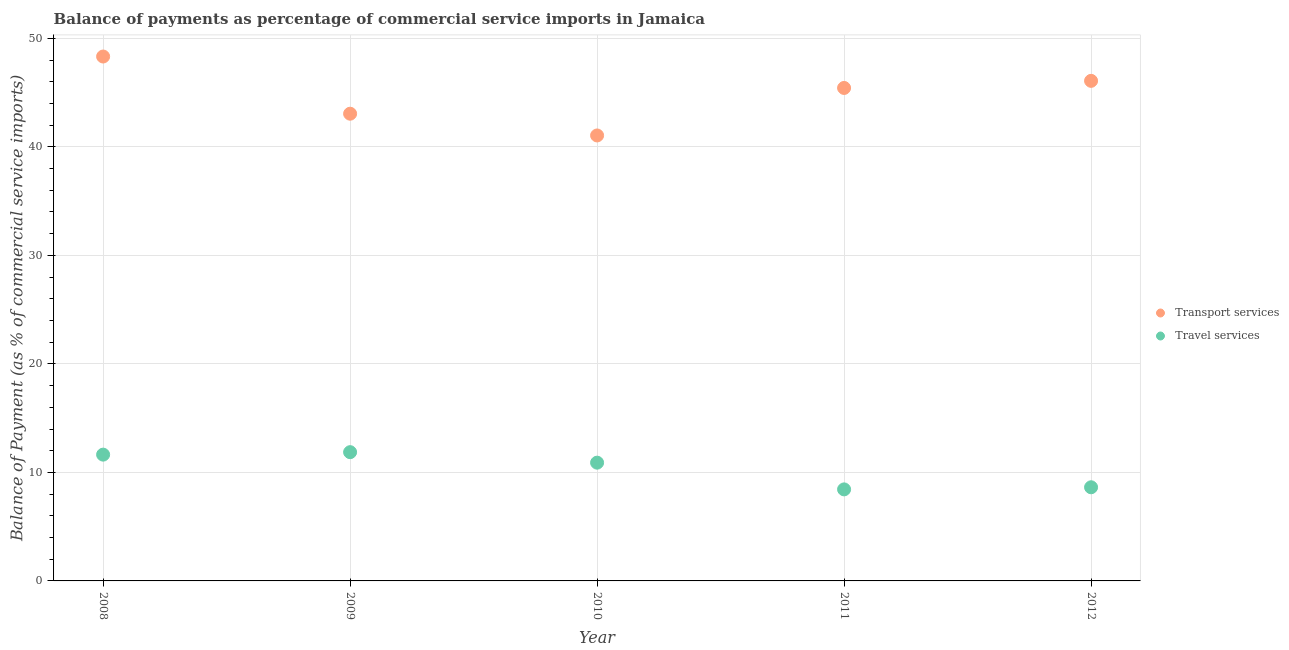How many different coloured dotlines are there?
Your response must be concise. 2. What is the balance of payments of travel services in 2012?
Make the answer very short. 8.63. Across all years, what is the maximum balance of payments of travel services?
Ensure brevity in your answer.  11.87. Across all years, what is the minimum balance of payments of travel services?
Provide a succinct answer. 8.44. What is the total balance of payments of travel services in the graph?
Make the answer very short. 51.47. What is the difference between the balance of payments of transport services in 2009 and that in 2012?
Your answer should be compact. -3.03. What is the difference between the balance of payments of transport services in 2011 and the balance of payments of travel services in 2008?
Make the answer very short. 33.79. What is the average balance of payments of travel services per year?
Your answer should be very brief. 10.29. In the year 2011, what is the difference between the balance of payments of travel services and balance of payments of transport services?
Provide a succinct answer. -36.99. In how many years, is the balance of payments of transport services greater than 26 %?
Offer a terse response. 5. What is the ratio of the balance of payments of travel services in 2008 to that in 2011?
Give a very brief answer. 1.38. Is the balance of payments of transport services in 2009 less than that in 2010?
Ensure brevity in your answer.  No. What is the difference between the highest and the second highest balance of payments of travel services?
Your answer should be very brief. 0.23. What is the difference between the highest and the lowest balance of payments of travel services?
Provide a succinct answer. 3.43. Is the balance of payments of transport services strictly greater than the balance of payments of travel services over the years?
Your answer should be very brief. Yes. Is the balance of payments of travel services strictly less than the balance of payments of transport services over the years?
Give a very brief answer. Yes. How many dotlines are there?
Your response must be concise. 2. How many years are there in the graph?
Make the answer very short. 5. Are the values on the major ticks of Y-axis written in scientific E-notation?
Keep it short and to the point. No. How are the legend labels stacked?
Offer a very short reply. Vertical. What is the title of the graph?
Provide a succinct answer. Balance of payments as percentage of commercial service imports in Jamaica. Does "Female entrants" appear as one of the legend labels in the graph?
Your answer should be compact. No. What is the label or title of the X-axis?
Your answer should be compact. Year. What is the label or title of the Y-axis?
Provide a short and direct response. Balance of Payment (as % of commercial service imports). What is the Balance of Payment (as % of commercial service imports) of Transport services in 2008?
Your response must be concise. 48.33. What is the Balance of Payment (as % of commercial service imports) of Travel services in 2008?
Offer a very short reply. 11.64. What is the Balance of Payment (as % of commercial service imports) of Transport services in 2009?
Provide a short and direct response. 43.06. What is the Balance of Payment (as % of commercial service imports) in Travel services in 2009?
Offer a terse response. 11.87. What is the Balance of Payment (as % of commercial service imports) of Transport services in 2010?
Provide a short and direct response. 41.05. What is the Balance of Payment (as % of commercial service imports) of Travel services in 2010?
Make the answer very short. 10.9. What is the Balance of Payment (as % of commercial service imports) of Transport services in 2011?
Provide a succinct answer. 45.43. What is the Balance of Payment (as % of commercial service imports) in Travel services in 2011?
Your response must be concise. 8.44. What is the Balance of Payment (as % of commercial service imports) of Transport services in 2012?
Ensure brevity in your answer.  46.09. What is the Balance of Payment (as % of commercial service imports) in Travel services in 2012?
Your answer should be compact. 8.63. Across all years, what is the maximum Balance of Payment (as % of commercial service imports) of Transport services?
Your response must be concise. 48.33. Across all years, what is the maximum Balance of Payment (as % of commercial service imports) in Travel services?
Offer a very short reply. 11.87. Across all years, what is the minimum Balance of Payment (as % of commercial service imports) in Transport services?
Your answer should be compact. 41.05. Across all years, what is the minimum Balance of Payment (as % of commercial service imports) of Travel services?
Your answer should be compact. 8.44. What is the total Balance of Payment (as % of commercial service imports) of Transport services in the graph?
Provide a short and direct response. 223.95. What is the total Balance of Payment (as % of commercial service imports) of Travel services in the graph?
Give a very brief answer. 51.47. What is the difference between the Balance of Payment (as % of commercial service imports) of Transport services in 2008 and that in 2009?
Your answer should be compact. 5.27. What is the difference between the Balance of Payment (as % of commercial service imports) of Travel services in 2008 and that in 2009?
Give a very brief answer. -0.23. What is the difference between the Balance of Payment (as % of commercial service imports) in Transport services in 2008 and that in 2010?
Keep it short and to the point. 7.27. What is the difference between the Balance of Payment (as % of commercial service imports) of Travel services in 2008 and that in 2010?
Your response must be concise. 0.74. What is the difference between the Balance of Payment (as % of commercial service imports) in Transport services in 2008 and that in 2011?
Your answer should be compact. 2.9. What is the difference between the Balance of Payment (as % of commercial service imports) in Travel services in 2008 and that in 2011?
Ensure brevity in your answer.  3.2. What is the difference between the Balance of Payment (as % of commercial service imports) of Transport services in 2008 and that in 2012?
Offer a terse response. 2.24. What is the difference between the Balance of Payment (as % of commercial service imports) in Travel services in 2008 and that in 2012?
Offer a terse response. 3.01. What is the difference between the Balance of Payment (as % of commercial service imports) of Transport services in 2009 and that in 2010?
Provide a short and direct response. 2. What is the difference between the Balance of Payment (as % of commercial service imports) of Travel services in 2009 and that in 2010?
Your response must be concise. 0.97. What is the difference between the Balance of Payment (as % of commercial service imports) of Transport services in 2009 and that in 2011?
Provide a succinct answer. -2.37. What is the difference between the Balance of Payment (as % of commercial service imports) in Travel services in 2009 and that in 2011?
Offer a very short reply. 3.43. What is the difference between the Balance of Payment (as % of commercial service imports) of Transport services in 2009 and that in 2012?
Keep it short and to the point. -3.03. What is the difference between the Balance of Payment (as % of commercial service imports) in Travel services in 2009 and that in 2012?
Your response must be concise. 3.24. What is the difference between the Balance of Payment (as % of commercial service imports) in Transport services in 2010 and that in 2011?
Offer a very short reply. -4.38. What is the difference between the Balance of Payment (as % of commercial service imports) in Travel services in 2010 and that in 2011?
Your answer should be compact. 2.46. What is the difference between the Balance of Payment (as % of commercial service imports) of Transport services in 2010 and that in 2012?
Your response must be concise. -5.03. What is the difference between the Balance of Payment (as % of commercial service imports) of Travel services in 2010 and that in 2012?
Offer a very short reply. 2.27. What is the difference between the Balance of Payment (as % of commercial service imports) of Transport services in 2011 and that in 2012?
Provide a succinct answer. -0.65. What is the difference between the Balance of Payment (as % of commercial service imports) of Travel services in 2011 and that in 2012?
Keep it short and to the point. -0.19. What is the difference between the Balance of Payment (as % of commercial service imports) of Transport services in 2008 and the Balance of Payment (as % of commercial service imports) of Travel services in 2009?
Offer a very short reply. 36.46. What is the difference between the Balance of Payment (as % of commercial service imports) in Transport services in 2008 and the Balance of Payment (as % of commercial service imports) in Travel services in 2010?
Keep it short and to the point. 37.43. What is the difference between the Balance of Payment (as % of commercial service imports) of Transport services in 2008 and the Balance of Payment (as % of commercial service imports) of Travel services in 2011?
Provide a short and direct response. 39.89. What is the difference between the Balance of Payment (as % of commercial service imports) of Transport services in 2008 and the Balance of Payment (as % of commercial service imports) of Travel services in 2012?
Your answer should be compact. 39.7. What is the difference between the Balance of Payment (as % of commercial service imports) of Transport services in 2009 and the Balance of Payment (as % of commercial service imports) of Travel services in 2010?
Keep it short and to the point. 32.16. What is the difference between the Balance of Payment (as % of commercial service imports) in Transport services in 2009 and the Balance of Payment (as % of commercial service imports) in Travel services in 2011?
Ensure brevity in your answer.  34.62. What is the difference between the Balance of Payment (as % of commercial service imports) in Transport services in 2009 and the Balance of Payment (as % of commercial service imports) in Travel services in 2012?
Your answer should be compact. 34.43. What is the difference between the Balance of Payment (as % of commercial service imports) in Transport services in 2010 and the Balance of Payment (as % of commercial service imports) in Travel services in 2011?
Keep it short and to the point. 32.62. What is the difference between the Balance of Payment (as % of commercial service imports) in Transport services in 2010 and the Balance of Payment (as % of commercial service imports) in Travel services in 2012?
Keep it short and to the point. 32.42. What is the difference between the Balance of Payment (as % of commercial service imports) of Transport services in 2011 and the Balance of Payment (as % of commercial service imports) of Travel services in 2012?
Provide a succinct answer. 36.8. What is the average Balance of Payment (as % of commercial service imports) of Transport services per year?
Provide a short and direct response. 44.79. What is the average Balance of Payment (as % of commercial service imports) in Travel services per year?
Make the answer very short. 10.29. In the year 2008, what is the difference between the Balance of Payment (as % of commercial service imports) of Transport services and Balance of Payment (as % of commercial service imports) of Travel services?
Offer a terse response. 36.69. In the year 2009, what is the difference between the Balance of Payment (as % of commercial service imports) of Transport services and Balance of Payment (as % of commercial service imports) of Travel services?
Your response must be concise. 31.19. In the year 2010, what is the difference between the Balance of Payment (as % of commercial service imports) of Transport services and Balance of Payment (as % of commercial service imports) of Travel services?
Provide a succinct answer. 30.15. In the year 2011, what is the difference between the Balance of Payment (as % of commercial service imports) in Transport services and Balance of Payment (as % of commercial service imports) in Travel services?
Your answer should be compact. 36.99. In the year 2012, what is the difference between the Balance of Payment (as % of commercial service imports) in Transport services and Balance of Payment (as % of commercial service imports) in Travel services?
Make the answer very short. 37.46. What is the ratio of the Balance of Payment (as % of commercial service imports) of Transport services in 2008 to that in 2009?
Your response must be concise. 1.12. What is the ratio of the Balance of Payment (as % of commercial service imports) in Travel services in 2008 to that in 2009?
Your response must be concise. 0.98. What is the ratio of the Balance of Payment (as % of commercial service imports) in Transport services in 2008 to that in 2010?
Offer a terse response. 1.18. What is the ratio of the Balance of Payment (as % of commercial service imports) in Travel services in 2008 to that in 2010?
Make the answer very short. 1.07. What is the ratio of the Balance of Payment (as % of commercial service imports) of Transport services in 2008 to that in 2011?
Offer a terse response. 1.06. What is the ratio of the Balance of Payment (as % of commercial service imports) of Travel services in 2008 to that in 2011?
Provide a short and direct response. 1.38. What is the ratio of the Balance of Payment (as % of commercial service imports) in Transport services in 2008 to that in 2012?
Provide a short and direct response. 1.05. What is the ratio of the Balance of Payment (as % of commercial service imports) in Travel services in 2008 to that in 2012?
Give a very brief answer. 1.35. What is the ratio of the Balance of Payment (as % of commercial service imports) of Transport services in 2009 to that in 2010?
Offer a terse response. 1.05. What is the ratio of the Balance of Payment (as % of commercial service imports) in Travel services in 2009 to that in 2010?
Your answer should be compact. 1.09. What is the ratio of the Balance of Payment (as % of commercial service imports) of Transport services in 2009 to that in 2011?
Provide a succinct answer. 0.95. What is the ratio of the Balance of Payment (as % of commercial service imports) in Travel services in 2009 to that in 2011?
Your answer should be compact. 1.41. What is the ratio of the Balance of Payment (as % of commercial service imports) in Transport services in 2009 to that in 2012?
Your response must be concise. 0.93. What is the ratio of the Balance of Payment (as % of commercial service imports) of Travel services in 2009 to that in 2012?
Your answer should be very brief. 1.37. What is the ratio of the Balance of Payment (as % of commercial service imports) in Transport services in 2010 to that in 2011?
Ensure brevity in your answer.  0.9. What is the ratio of the Balance of Payment (as % of commercial service imports) of Travel services in 2010 to that in 2011?
Your answer should be very brief. 1.29. What is the ratio of the Balance of Payment (as % of commercial service imports) of Transport services in 2010 to that in 2012?
Provide a short and direct response. 0.89. What is the ratio of the Balance of Payment (as % of commercial service imports) of Travel services in 2010 to that in 2012?
Provide a succinct answer. 1.26. What is the ratio of the Balance of Payment (as % of commercial service imports) of Transport services in 2011 to that in 2012?
Provide a succinct answer. 0.99. What is the ratio of the Balance of Payment (as % of commercial service imports) of Travel services in 2011 to that in 2012?
Provide a succinct answer. 0.98. What is the difference between the highest and the second highest Balance of Payment (as % of commercial service imports) of Transport services?
Your answer should be compact. 2.24. What is the difference between the highest and the second highest Balance of Payment (as % of commercial service imports) in Travel services?
Offer a very short reply. 0.23. What is the difference between the highest and the lowest Balance of Payment (as % of commercial service imports) in Transport services?
Make the answer very short. 7.27. What is the difference between the highest and the lowest Balance of Payment (as % of commercial service imports) in Travel services?
Make the answer very short. 3.43. 